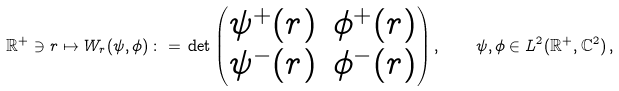Convert formula to latex. <formula><loc_0><loc_0><loc_500><loc_500>\mathbb { R } ^ { + } \ni r \mapsto W _ { r } ( \psi , \phi ) \, \colon = \, \det \begin{pmatrix} \psi ^ { + } ( r ) & \phi ^ { + } ( r ) \\ \psi ^ { - } ( r ) & \phi ^ { - } ( r ) \end{pmatrix} , \quad \psi , \phi \in L ^ { 2 } ( \mathbb { R } ^ { + } , \mathbb { C } ^ { 2 } ) \, ,</formula> 